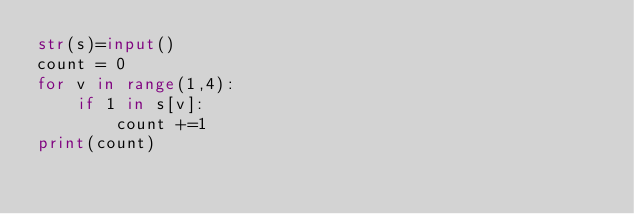Convert code to text. <code><loc_0><loc_0><loc_500><loc_500><_Python_>str(s)=input()
count = 0
for v in range(1,4):
    if 1 in s[v]:
        count +=1
print(count)</code> 